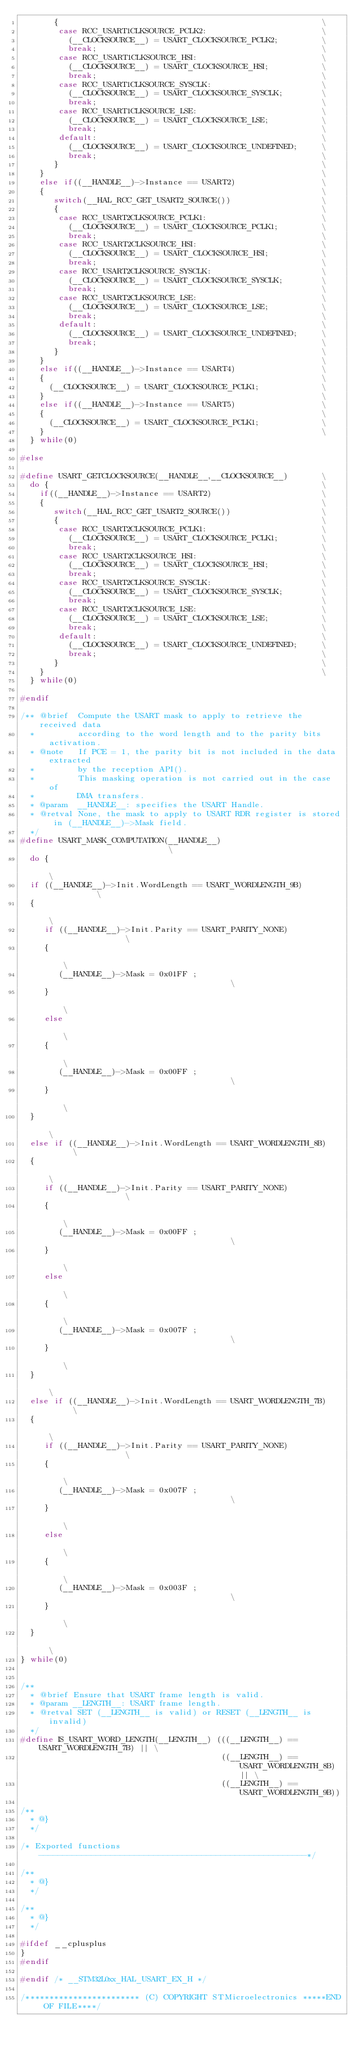<code> <loc_0><loc_0><loc_500><loc_500><_C_>       {                                                       \
        case RCC_USART1CLKSOURCE_PCLK2:                        \
          (__CLOCKSOURCE__) = USART_CLOCKSOURCE_PCLK2;         \
          break;                                               \
        case RCC_USART1CLKSOURCE_HSI:                          \
          (__CLOCKSOURCE__) = USART_CLOCKSOURCE_HSI;           \
          break;                                               \
        case RCC_USART1CLKSOURCE_SYSCLK:                       \
          (__CLOCKSOURCE__) = USART_CLOCKSOURCE_SYSCLK;        \
          break;                                               \
        case RCC_USART1CLKSOURCE_LSE:                          \
          (__CLOCKSOURCE__) = USART_CLOCKSOURCE_LSE;           \
          break;                                               \
        default:                                               \
          (__CLOCKSOURCE__) = USART_CLOCKSOURCE_UNDEFINED;     \
          break;                                               \
       }                                                       \
    }                                                          \
    else if((__HANDLE__)->Instance == USART2)                  \
    {                                                          \
       switch(__HAL_RCC_GET_USART2_SOURCE())                   \
       {                                                       \
        case RCC_USART2CLKSOURCE_PCLK1:                        \
          (__CLOCKSOURCE__) = USART_CLOCKSOURCE_PCLK1;         \
          break;                                               \
        case RCC_USART2CLKSOURCE_HSI:                          \
          (__CLOCKSOURCE__) = USART_CLOCKSOURCE_HSI;           \
          break;                                               \
        case RCC_USART2CLKSOURCE_SYSCLK:                       \
          (__CLOCKSOURCE__) = USART_CLOCKSOURCE_SYSCLK;        \
          break;                                               \
        case RCC_USART2CLKSOURCE_LSE:                          \
          (__CLOCKSOURCE__) = USART_CLOCKSOURCE_LSE;           \
          break;                                               \
        default:                                               \
          (__CLOCKSOURCE__) = USART_CLOCKSOURCE_UNDEFINED;     \
          break;                                               \
       }                                                       \
    }                                                          \
    else if((__HANDLE__)->Instance == USART4)                  \
    {                                                          \
      (__CLOCKSOURCE__) = USART_CLOCKSOURCE_PCLK1;             \
    }                                                          \
    else if((__HANDLE__)->Instance == USART5)                  \
    {                                                          \
      (__CLOCKSOURCE__) = USART_CLOCKSOURCE_PCLK1;             \
    }                                                          \
  } while(0)

#else

#define USART_GETCLOCKSOURCE(__HANDLE__,__CLOCKSOURCE__)       \
  do {                                                         \
    if((__HANDLE__)->Instance == USART2)                       \
    {                                                          \
       switch(__HAL_RCC_GET_USART2_SOURCE())                   \
       {                                                       \
        case RCC_USART2CLKSOURCE_PCLK1:                        \
          (__CLOCKSOURCE__) = USART_CLOCKSOURCE_PCLK1;         \
          break;                                               \
        case RCC_USART2CLKSOURCE_HSI:                          \
          (__CLOCKSOURCE__) = USART_CLOCKSOURCE_HSI;           \
          break;                                               \
        case RCC_USART2CLKSOURCE_SYSCLK:                       \
          (__CLOCKSOURCE__) = USART_CLOCKSOURCE_SYSCLK;        \
          break;                                               \
        case RCC_USART2CLKSOURCE_LSE:                          \
          (__CLOCKSOURCE__) = USART_CLOCKSOURCE_LSE;           \
          break;                                               \
        default:                                               \
          (__CLOCKSOURCE__) = USART_CLOCKSOURCE_UNDEFINED;     \
          break;                                               \
       }                                                       \
    }                                                          \
  } while(0)

#endif

/** @brief  Compute the USART mask to apply to retrieve the received data
  *         according to the word length and to the parity bits activation.
  * @note   If PCE = 1, the parity bit is not included in the data extracted
  *         by the reception API().
  *         This masking operation is not carried out in the case of
  *         DMA transfers.
  * @param  __HANDLE__: specifies the USART Handle.
  * @retval None, the mask to apply to USART RDR register is stored in (__HANDLE__)->Mask field.
  */
#define USART_MASK_COMPUTATION(__HANDLE__)                            \
  do {                                                                \
  if ((__HANDLE__)->Init.WordLength == USART_WORDLENGTH_9B)           \
  {                                                                   \
     if ((__HANDLE__)->Init.Parity == USART_PARITY_NONE)              \
     {                                                                \
        (__HANDLE__)->Mask = 0x01FF ;                                 \
     }                                                                \
     else                                                             \
     {                                                                \
        (__HANDLE__)->Mask = 0x00FF ;                                 \
     }                                                                \
  }                                                                   \
  else if ((__HANDLE__)->Init.WordLength == USART_WORDLENGTH_8B)      \
  {                                                                   \
     if ((__HANDLE__)->Init.Parity == USART_PARITY_NONE)              \
     {                                                                \
        (__HANDLE__)->Mask = 0x00FF ;                                 \
     }                                                                \
     else                                                             \
     {                                                                \
        (__HANDLE__)->Mask = 0x007F ;                                 \
     }                                                                \
  }                                                                   \
  else if ((__HANDLE__)->Init.WordLength == USART_WORDLENGTH_7B)      \
  {                                                                   \
     if ((__HANDLE__)->Init.Parity == USART_PARITY_NONE)              \
     {                                                                \
        (__HANDLE__)->Mask = 0x007F ;                                 \
     }                                                                \
     else                                                             \
     {                                                                \
        (__HANDLE__)->Mask = 0x003F ;                                 \
     }                                                                \
  }                                                                   \
} while(0)


/**
  * @brief Ensure that USART frame length is valid.
  * @param __LENGTH__: USART frame length. 
  * @retval SET (__LENGTH__ is valid) or RESET (__LENGTH__ is invalid)
  */
#define IS_USART_WORD_LENGTH(__LENGTH__) (((__LENGTH__) == USART_WORDLENGTH_7B) || \
                                          ((__LENGTH__) == USART_WORDLENGTH_8B) || \
                                          ((__LENGTH__) == USART_WORDLENGTH_9B))

/**
  * @}
  */

/* Exported functions --------------------------------------------------------*/

/**
  * @}
  */

/**
  * @}
  */

#ifdef __cplusplus
}
#endif

#endif /* __STM32L0xx_HAL_USART_EX_H */

/************************ (C) COPYRIGHT STMicroelectronics *****END OF FILE****/

</code> 